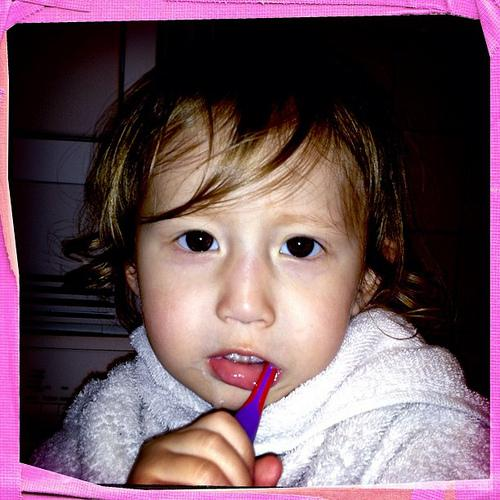Question: what is the child doing?
Choices:
A. Flossing.
B. Dental care.
C. Brushing its teeth.
D. Using toothpaste.
Answer with the letter. Answer: C Question: where is this scene?
Choices:
A. Bathroom.
B. Restroom.
C. Ladies room.
D. Commode.
Answer with the letter. Answer: A Question: what colors are the toothbrush?
Choices:
A. Magenta and purple.
B. Pink and red.
C. Red and white.
D. White and blue.
Answer with the letter. Answer: A Question: what is the child wearing?
Choices:
A. A robe.
B. Gown.
C. Cover up.
D. Bathrobe.
Answer with the letter. Answer: A Question: what color is the robe?
Choices:
A. Red.
B. Black.
C. Brown.
D. White.
Answer with the letter. Answer: D Question: who is brushing their teeth?
Choices:
A. A toddler.
B. His son.
C. His daughter.
D. A child.
Answer with the letter. Answer: D Question: when is this?
Choices:
A. Evening.
B. Night time.
C. After dark.
D. Bed time.
Answer with the letter. Answer: B 